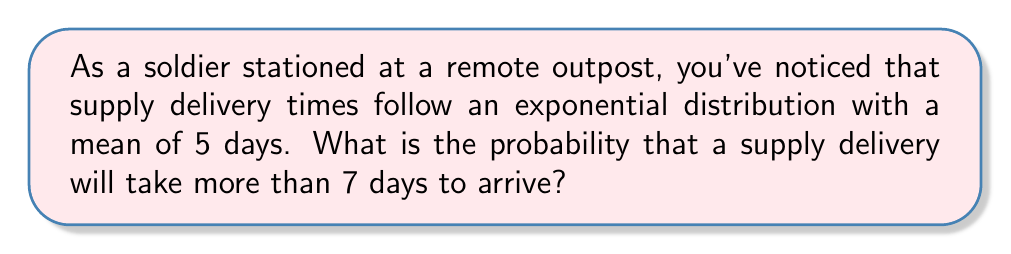Could you help me with this problem? Let's approach this step-by-step:

1) The exponential distribution is given by the probability density function:
   $$f(x) = \lambda e^{-\lambda x}$$
   where $\lambda$ is the rate parameter.

2) We're given that the mean is 5 days. For an exponential distribution, the mean is equal to $\frac{1}{\lambda}$. So:
   $$5 = \frac{1}{\lambda}$$
   $$\lambda = \frac{1}{5}$$

3) We want to find $P(X > 7)$, where X is the delivery time in days.

4) For an exponential distribution:
   $$P(X > x) = e^{-\lambda x}$$

5) Substituting our values:
   $$P(X > 7) = e^{-\frac{1}{5} \cdot 7}$$

6) Simplifying:
   $$P(X > 7) = e^{-\frac{7}{5}}$$

7) Using a calculator:
   $$P(X > 7) \approx 0.2466$$

Thus, the probability that a supply delivery will take more than 7 days is approximately 0.2466 or 24.66%.
Answer: $e^{-\frac{7}{5}} \approx 0.2466$ 